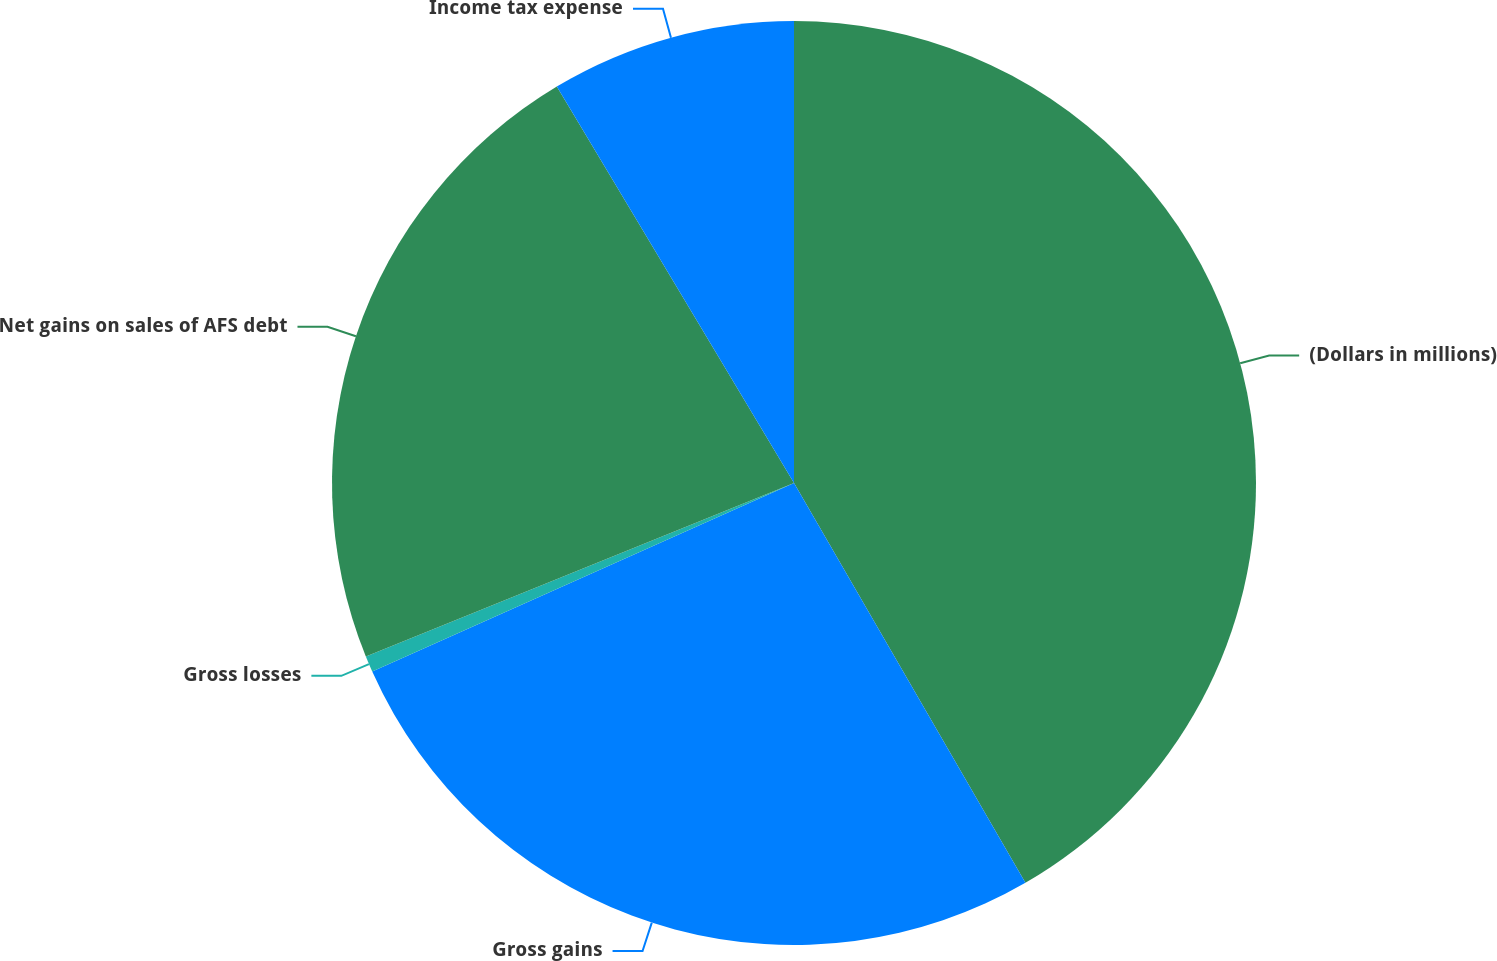Convert chart to OTSL. <chart><loc_0><loc_0><loc_500><loc_500><pie_chart><fcel>(Dollars in millions)<fcel>Gross gains<fcel>Gross losses<fcel>Net gains on sales of AFS debt<fcel>Income tax expense<nl><fcel>41.65%<fcel>26.66%<fcel>0.56%<fcel>22.55%<fcel>8.58%<nl></chart> 